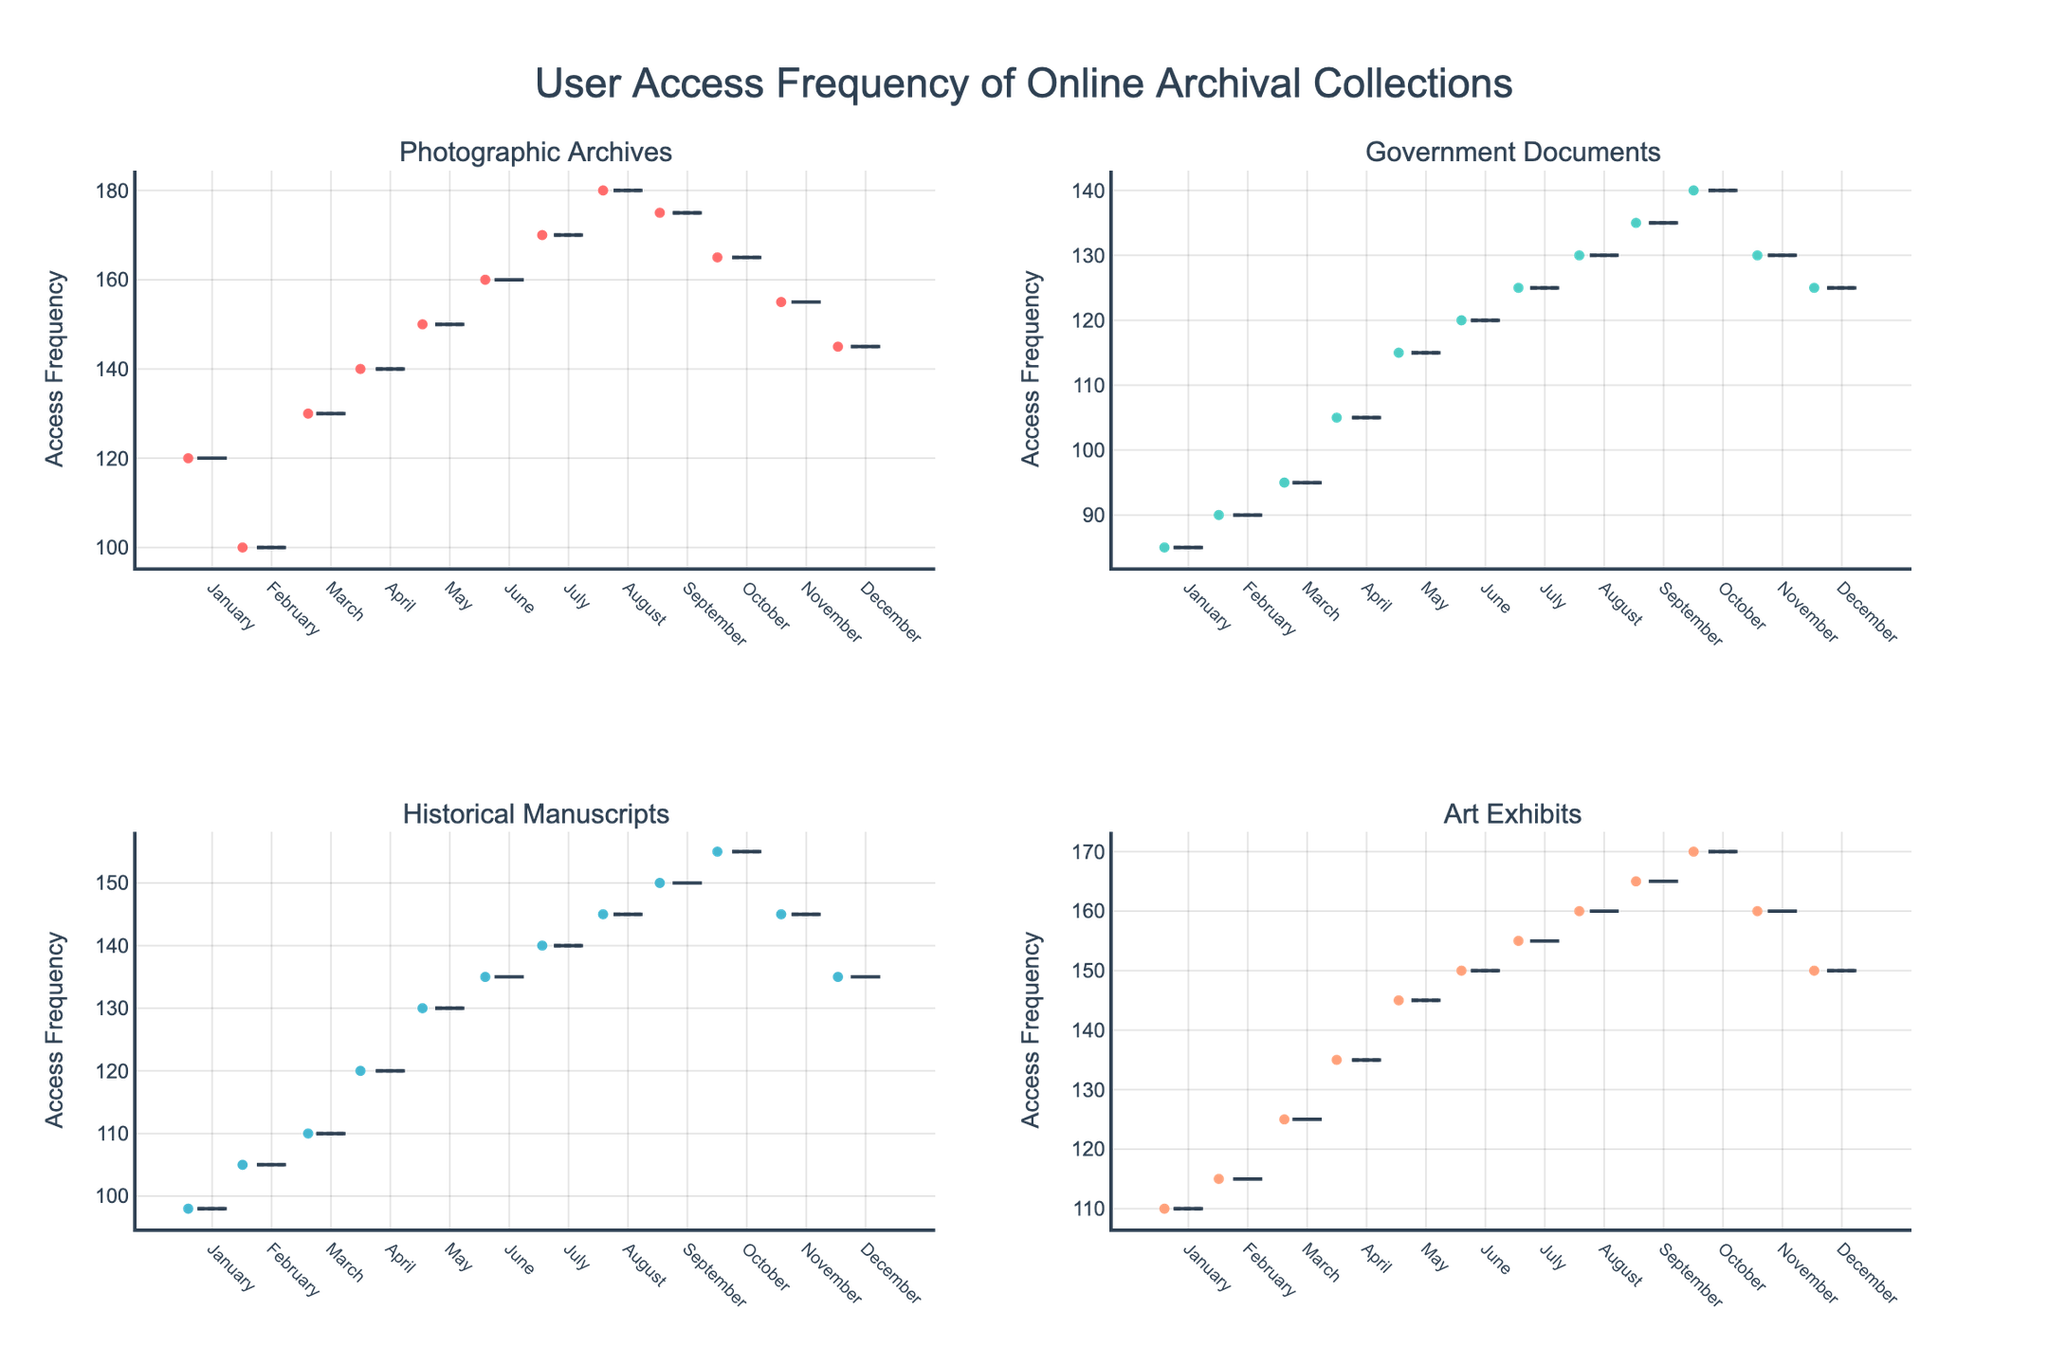What's the title of the figure? The title of a figure is usually found at the top and is typically the largest text size present. In this figure, the title displayed at the top is "User Access Frequency of Online Archival Collections."
Answer: User Access Frequency of Online Archival Collections How many subplots are present in the figure? By visually inspecting the layout of the figure, we can see it is divided into four distinct subplots, each representing a different archival collection.
Answer: 4 Which collection has the highest median access frequency in August? To determine this, examine the box plots for each collection in the figure and look for the median line inside the box for August. The "Photographic Archives" collection has the highest median access frequency.
Answer: Photographic Archives What is the general trend of user access frequency for Government Documents across the months? Observing the box plot for Government Documents, the general access frequency shows a steady increase from January to October, followed by a slight decrease in November and December.
Answer: Increase until October, then decrease Which collection has the most consistent user access frequency over the months? Consistency in access frequency is indicated by the least spread in the box plots. By examining the interquartile ranges (IQR) of the box plots, the "Government Documents" appears to have the least variability.
Answer: Government Documents Compare the April access frequency for Historical Manuscripts and Art Exhibits. Which one is higher? Look at the median lines of the box plots for both Historical Manuscripts and Art Exhibits in April. The median line for Art Exhibits is higher than that for Historical Manuscripts.
Answer: Art Exhibits Is there a month where all collections have a higher user access frequency compared to January? If so, which month? By comparing the January box plots' access frequencies with those of subsequent months, June, July, August, September, and October all show higher access frequencies across all collections compared to January.
Answer: June, July, August, September, October What is the average range of access frequency in July for Photographic Archives and Art Exhibits? Calculate the range (difference between maximum and minimum values) for July by inspecting the ends of the whiskers for Photographic Archives and Art Exhibits. Average the two ranges: 
Photographic Archives: 170 (max) - 170 (min) = 0 
Art Exhibits: 155 (max) - 155 (min) = 0 
Average Range: (0 + 0) / 2 = 0
Answer: 0 Inspecting the median access frequency, which collection had the least variation across the year? To find the least variation, compare the median values across all boxes for each collection. Collections with medians close to each other (less spread) indicate less variation. "Government Documents" shows the least variation in median access frequency over the year.
Answer: Government Documents What is the box plot color for Historical Manuscripts? The box plots have different colors for each collection. Examining the figure, the color used for Historical Manuscripts is turquoise.
Answer: Turquoise 